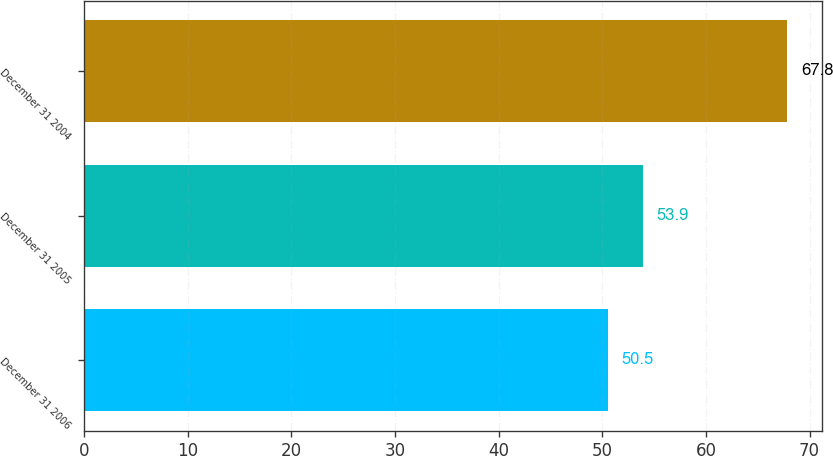Convert chart. <chart><loc_0><loc_0><loc_500><loc_500><bar_chart><fcel>December 31 2006<fcel>December 31 2005<fcel>December 31 2004<nl><fcel>50.5<fcel>53.9<fcel>67.8<nl></chart> 